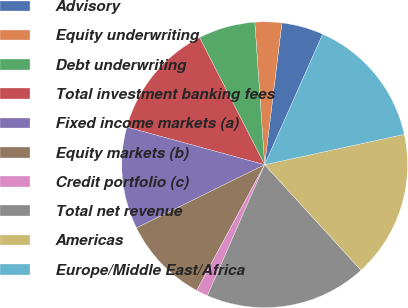Convert chart to OTSL. <chart><loc_0><loc_0><loc_500><loc_500><pie_chart><fcel>Advisory<fcel>Equity underwriting<fcel>Debt underwriting<fcel>Total investment banking fees<fcel>Fixed income markets (a)<fcel>Equity markets (b)<fcel>Credit portfolio (c)<fcel>Total net revenue<fcel>Americas<fcel>Europe/Middle East/Africa<nl><fcel>4.73%<fcel>3.03%<fcel>6.43%<fcel>13.23%<fcel>11.53%<fcel>9.83%<fcel>1.32%<fcel>18.34%<fcel>16.63%<fcel>14.93%<nl></chart> 